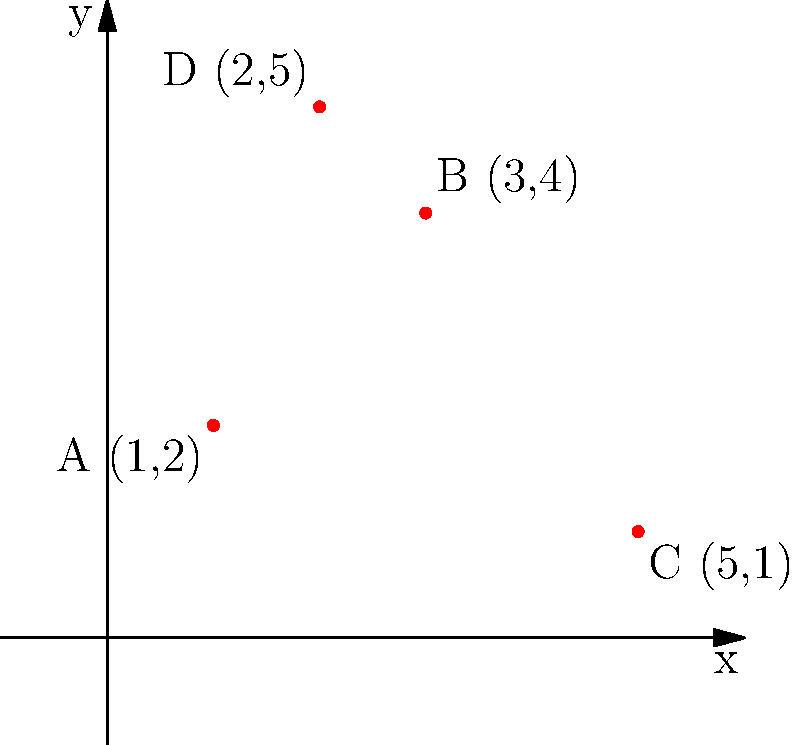You're planning a coffee shop crawl for your neighbors. On a coordinate plane, you've plotted the locations of four local coffee shops: A(1,2), B(3,4), C(5,1), and D(2,5). What is the total distance you'll walk if you visit all four shops in alphabetical order (A to B to C to D) and return to shop A? Let's break this down step-by-step:

1) First, we need to calculate the distance between each pair of points using the distance formula: 
   $d = \sqrt{(x_2-x_1)^2 + (y_2-y_1)^2}$

2) Distance from A to B:
   $AB = \sqrt{(3-1)^2 + (4-2)^2} = \sqrt{4 + 4} = \sqrt{8} = 2\sqrt{2}$

3) Distance from B to C:
   $BC = \sqrt{(5-3)^2 + (1-4)^2} = \sqrt{4 + 9} = \sqrt{13}$

4) Distance from C to D:
   $CD = \sqrt{(2-5)^2 + (5-1)^2} = \sqrt{9 + 16} = 5$

5) Distance from D back to A:
   $DA = \sqrt{(1-2)^2 + (2-5)^2} = \sqrt{1 + 9} = \sqrt{10}$

6) Total distance is the sum of all these distances:
   $Total = 2\sqrt{2} + \sqrt{13} + 5 + \sqrt{10}$

7) This can be simplified to:
   $Total = 2\sqrt{2} + \sqrt{13} + 5 + \sqrt{10} \approx 13.07$ units
Answer: $2\sqrt{2} + \sqrt{13} + 5 + \sqrt{10}$ units 